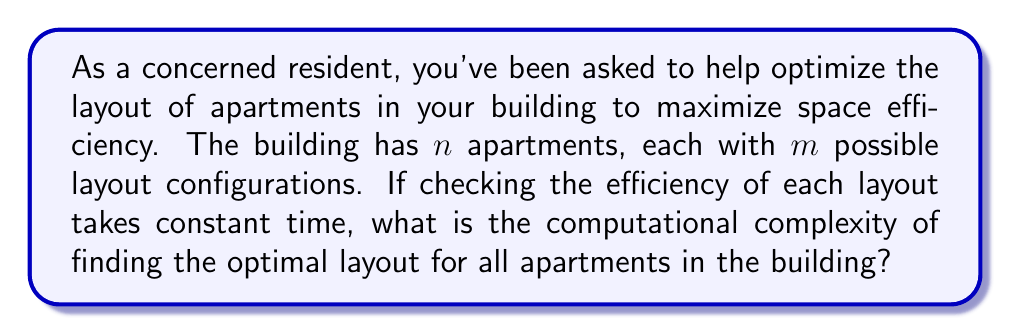Can you solve this math problem? To solve this problem, we need to consider the following steps:

1. For each apartment, we have $m$ possible layouts to consider.
2. We have $n$ apartments in total.
3. To find the optimal layout for all apartments, we need to check all possible combinations of layouts.

The number of combinations is determined by the multiplication principle:

$$ \text{Total combinations} = m \times m \times \cdots \times m \text{ ($n$ times)} = m^n $$

For each combination, we need to check its efficiency, which takes constant time. Let's call this constant time $c$.

Therefore, the total time complexity is:

$$ T(n) = c \times m^n $$

In Big O notation, we ignore constant factors, so we can simplify this to:

$$ T(n) = O(m^n) $$

This is an exponential time complexity, which means the problem becomes intractable for large values of $n$ and $m$.

In terms of computational complexity theory, this problem is similar to the "apartment layout optimization" version of the Set Cover problem, which is known to be NP-hard. This means that there is likely no polynomial-time algorithm to solve this problem optimally for all cases.
Answer: The computational complexity of optimizing apartment layouts in a building with $n$ apartments and $m$ possible layouts per apartment is $O(m^n)$, which is exponential time complexity. 